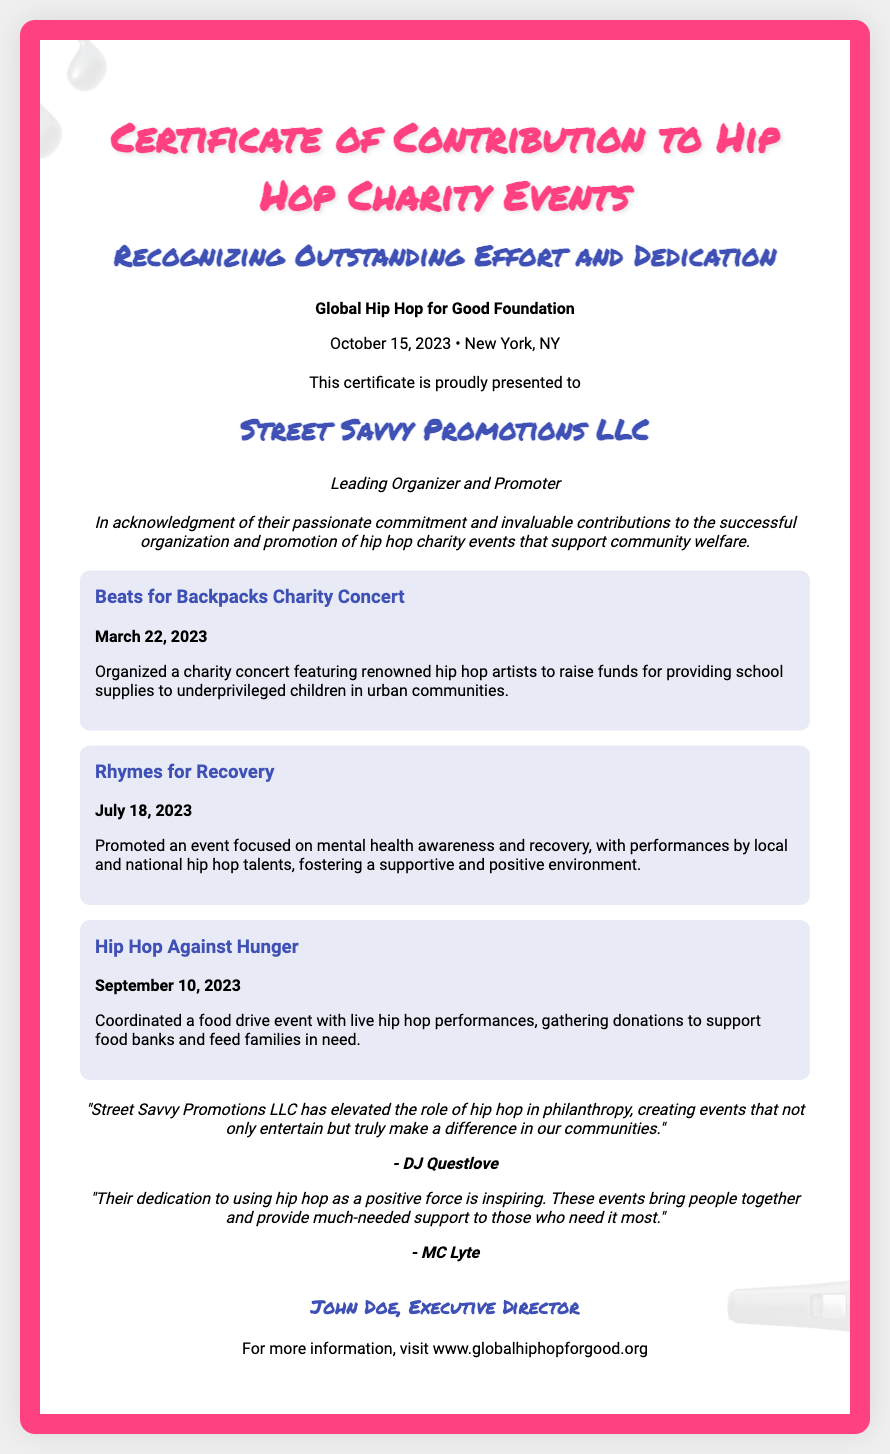What is the name of the organization issuing the certificate? The issuer of the certificate is indicated at the top part of the document as "Global Hip Hop for Good Foundation."
Answer: Global Hip Hop for Good Foundation What is the date of issuance for the certificate? The date of issuance is clearly stated in the issuer's information section, which is "October 15, 2023."
Answer: October 15, 2023 Who is the recipient of the certificate? The recipient's name is prominently highlighted in the document, reading "Street Savvy Promotions LLC."
Answer: Street Savvy Promotions LLC How many charity events are mentioned in the document? Three distinct charity events are listed in the achievements section of the document.
Answer: Three What is the title given to the recipient? The document describes the recipient with the title "Leading Organizer and Promoter."
Answer: Leading Organizer and Promoter What is the title of the first charity event listed? The first event mentioned in the achievements section is titled "Beats for Backpacks Charity Concert."
Answer: Beats for Backpacks Charity Concert What is DJ Questlove's role in the document? DJ Questlove is mentioned as a person providing a testimonial, indicating their opinion on the contributions of the recipient.
Answer: Testimonial provider Which type of event does "Rhymes for Recovery" focus on? The focus of the "Rhymes for Recovery" event is specified in the achievements section as "mental health awareness and recovery."
Answer: Mental health awareness and recovery What is the website provided in the footer for more information? The footer contains the website URL for additional information, which is "www.globalhiphopforgood.org."
Answer: www.globalhiphopforgood.org 